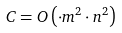Convert formula to latex. <formula><loc_0><loc_0><loc_500><loc_500>C = O \left ( \cdot m ^ { 2 } \cdot n ^ { 2 } \right )</formula> 